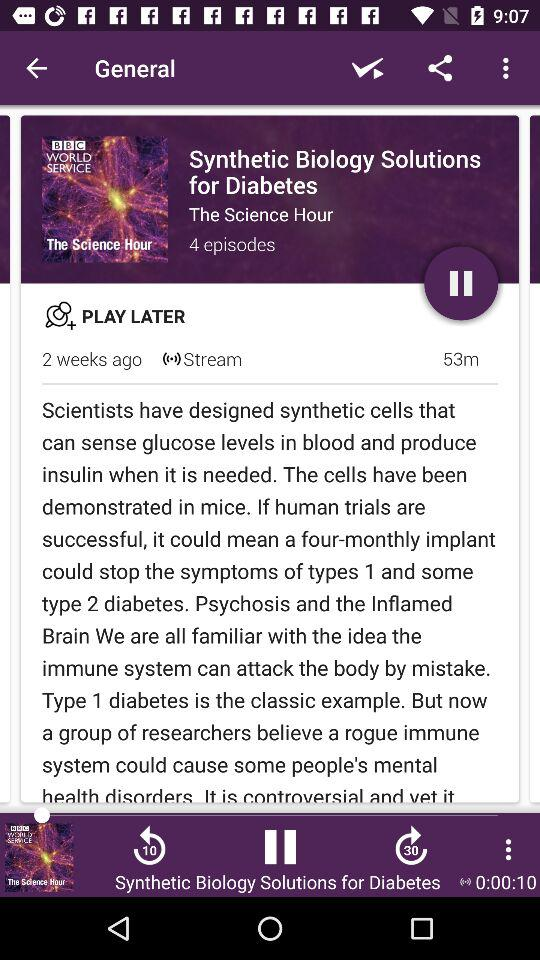How many episodes are there in the series? The series 'Synthetic Biology Solutions for Diabetes' featured in the BBC World Service podcast consists of four episodes. Each episode delves into different aspects of how synthetic biology could revolutionize the treatment of diabetes. 